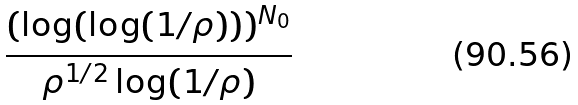Convert formula to latex. <formula><loc_0><loc_0><loc_500><loc_500>\frac { ( \log ( \log ( 1 / \rho ) ) ) ^ { N _ { 0 } } } { \rho ^ { 1 / 2 } \log ( 1 / \rho ) }</formula> 